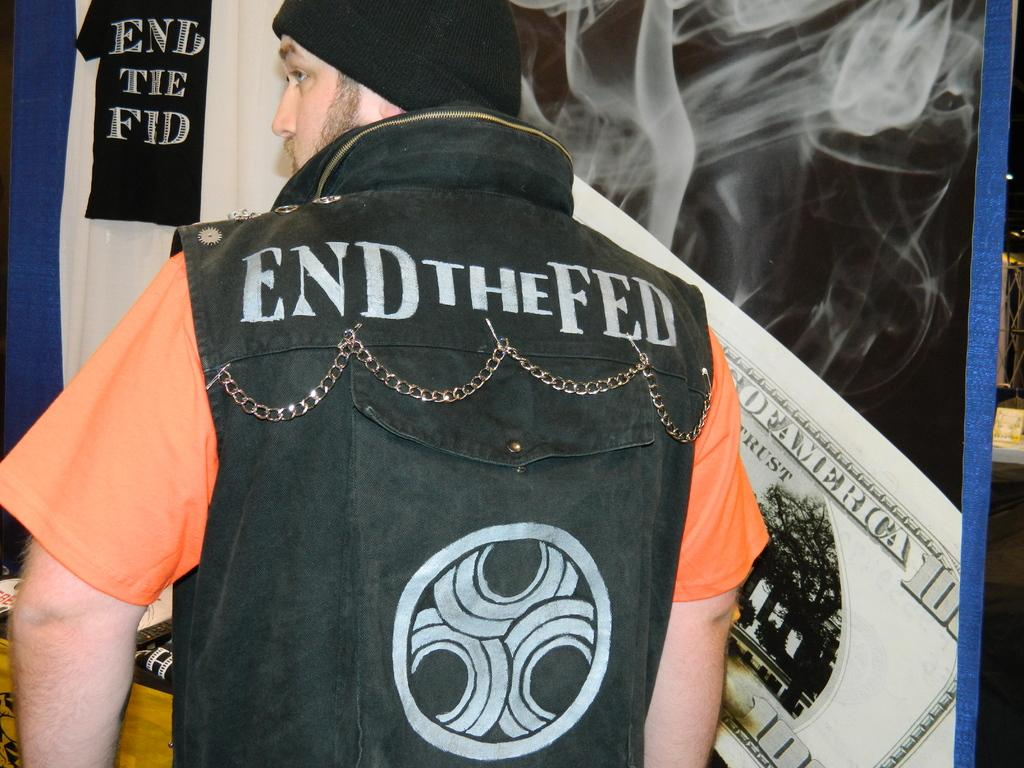<image>
Summarize the visual content of the image. A man wears an End the Fed vest over an orange T shirt. 